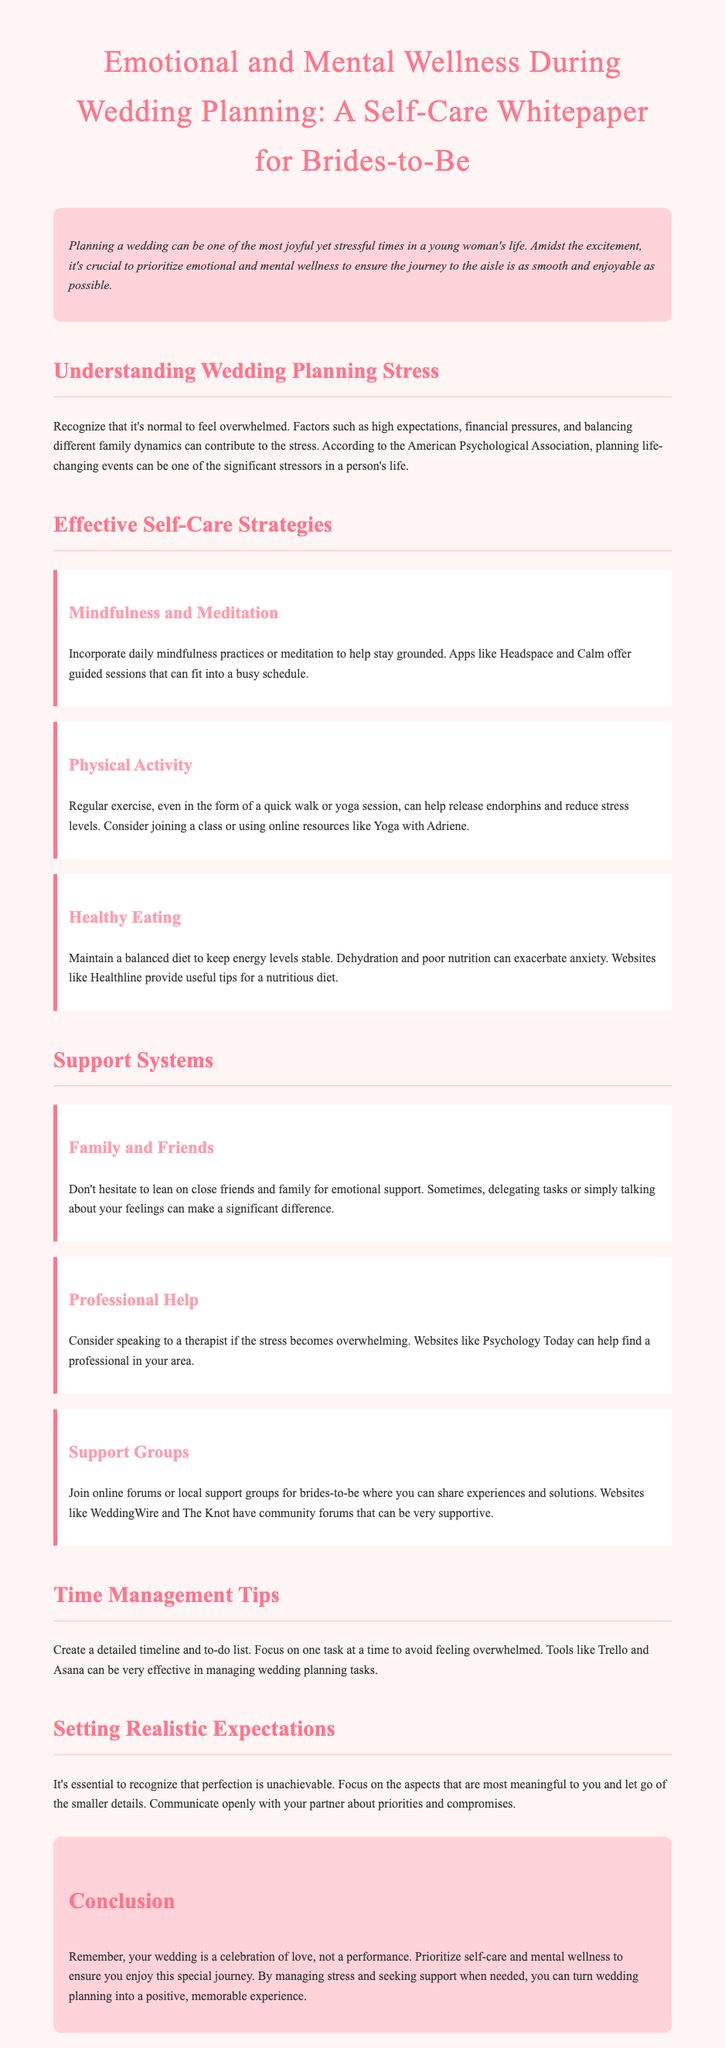what is the title of the whitepaper? The title is presented prominently at the top of the document.
Answer: Emotional and Mental Wellness During Wedding Planning: A Self-Care Whitepaper for Brides-to-Be what is one of the main contributors to wedding planning stress? The document discusses various factors, including financial pressures, as contributing to stress.
Answer: Financial pressures name one mindfulness app mentioned in the whitepaper. Specific apps for mindfulness are referenced in the document.
Answer: Headspace what can help release endorphins according to the whitepaper? The document advises on physical activities that contribute to emotional wellness.
Answer: Regular exercise how should brides-to-be manage time according to the document? The whitepaper suggests creating a detailed plan for tasks to avoid feeling overwhelmed.
Answer: Create a detailed timeline and to-do list what should brides prioritize according to the conclusion? The conclusion emphasizes the importance of self-care during wedding planning.
Answer: Self-care what is a suggested way to seek professional help if overwhelmed? The document provides advice on finding support when stress is high.
Answer: Speaking to a therapist what type of groups does the document suggest joining? The whitepaper recommends joining specific types of communities for help.
Answer: Support groups 